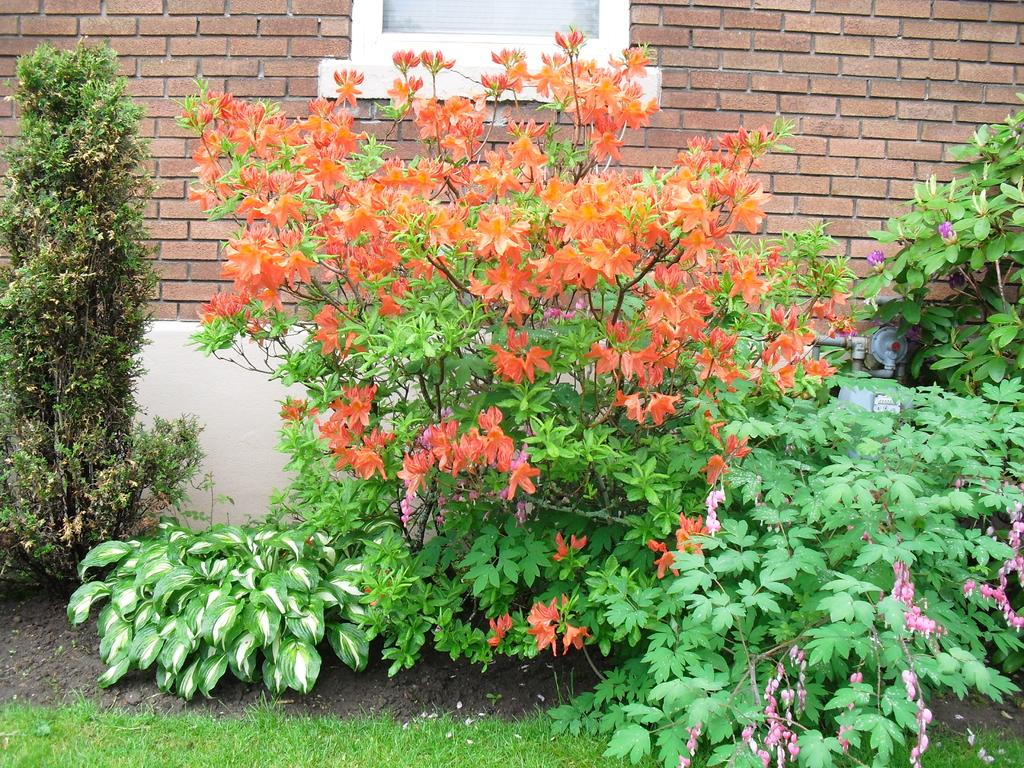What celestial bodies are depicted in the image? There are planets in the image. What type of vegetation can be seen in the image? There is grass visible in the image. What architectural feature is present in the background of the image? There is a brick wall in the background of the image. What can be seen through the window in the background of the image? There is a window in the background of the image. What type of pickle is growing under the window in the image? There is no pickle present in the image; the image features planets, grass, a brick wall, and a window. What color is the cherry on the brick wall in the image? There is no cherry present on the brick wall in the image. 